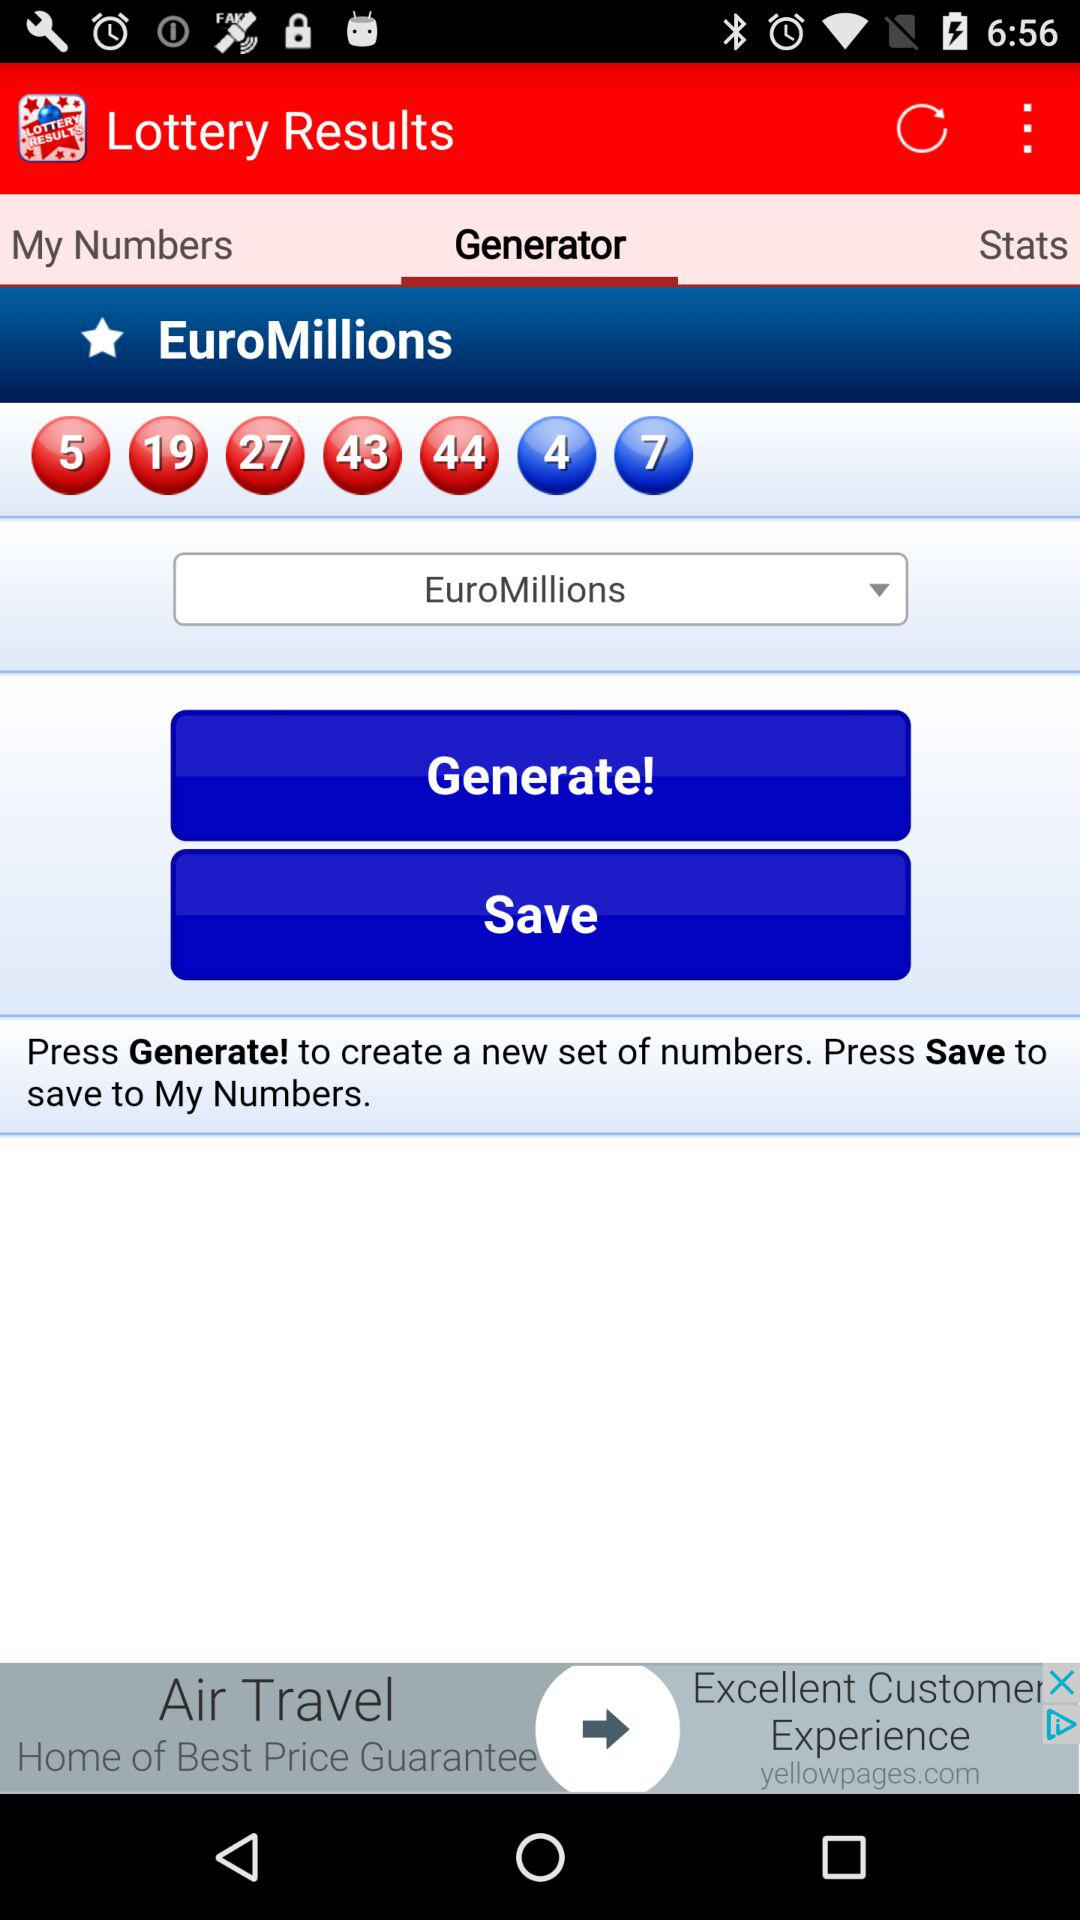How many numbers are in the generated set?
Answer the question using a single word or phrase. 7 